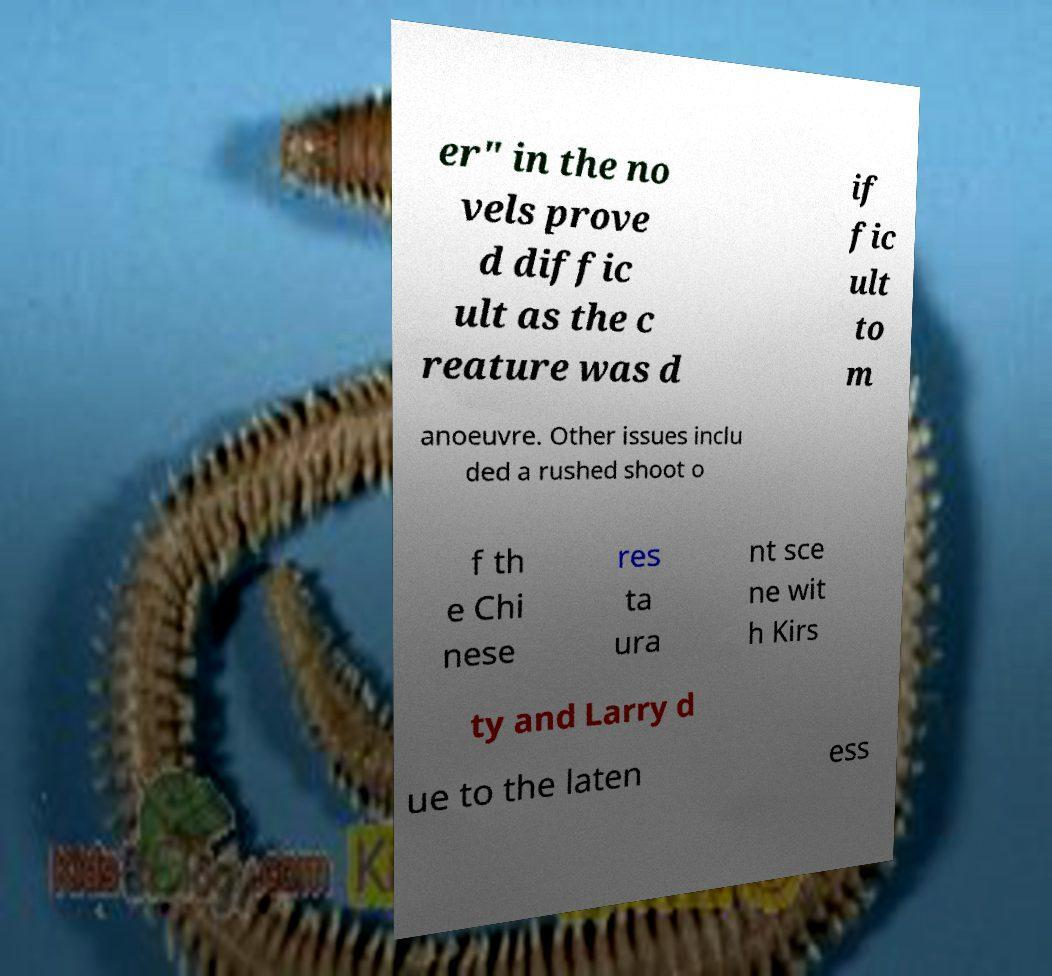For documentation purposes, I need the text within this image transcribed. Could you provide that? er" in the no vels prove d diffic ult as the c reature was d if fic ult to m anoeuvre. Other issues inclu ded a rushed shoot o f th e Chi nese res ta ura nt sce ne wit h Kirs ty and Larry d ue to the laten ess 